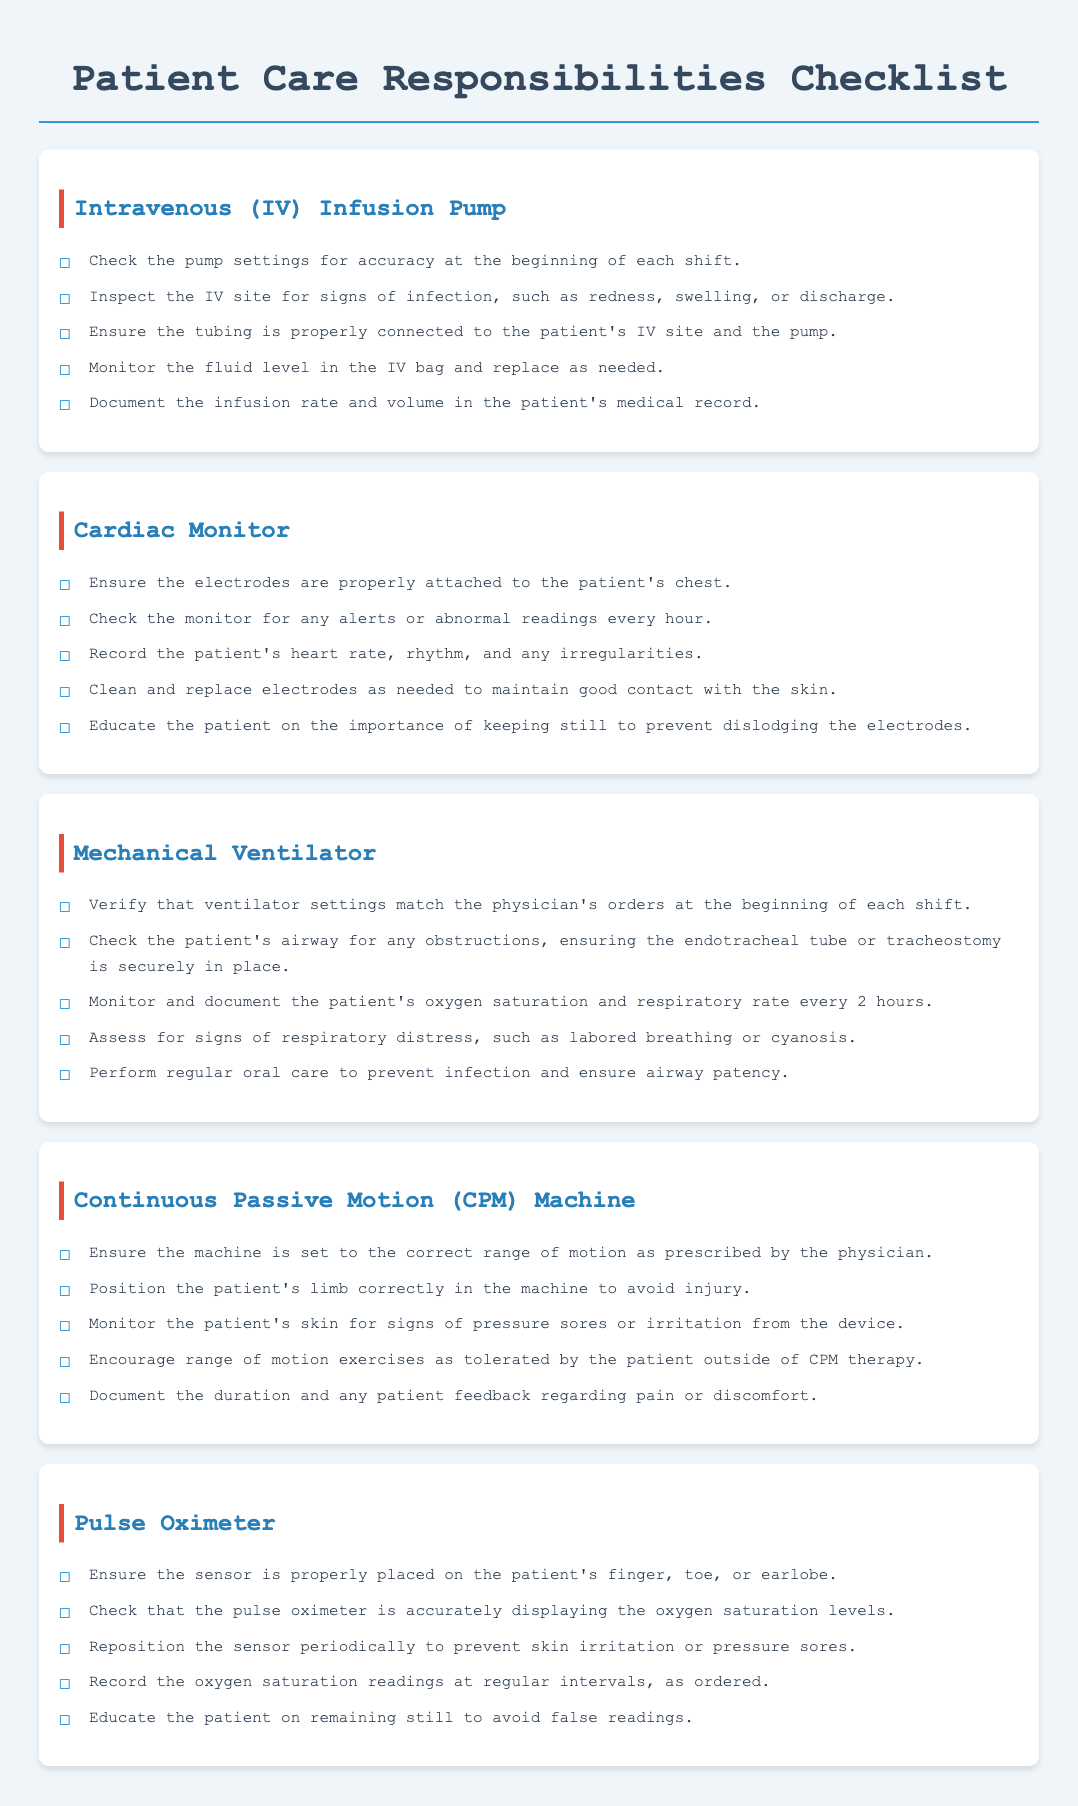What are the responsibilities for an IV infusion pump? The responsibilities for an IV infusion pump are listed in the corresponding section of the document under "Intravenous (IV) Infusion Pump."
Answer: Check the pump settings for accuracy at the beginning of each shift, inspect the IV site for signs of infection, ensure the tubing is properly connected, monitor the fluid level in the IV bag, and document the infusion rate and volume How often should the cardiac monitor be checked for alerts? The document states that the cardiac monitor should be checked for alerts "every hour."
Answer: Every hour What should be documented for the mechanical ventilator? The responsibilities include monitoring and documenting the patient's oxygen saturation and respiratory rate, as well as ventilator settings.
Answer: The patient's oxygen saturation and respiratory rate What is a key patient education point for the pulse oximeter? The document emphasizes that the patient should be educated on remaining still to avoid false readings from the pulse oximeter.
Answer: Remaining still How frequently should skin be monitored when using a CPM machine? The document suggests monitoring the patient's skin for signs of pressure sores or irritation regularly, but does not specify a frequency.
Answer: Regularly What type of device is checked for accuracy at the start of each shift? The document specifies that the IV infusion pump is checked for accuracy at the beginning of each shift.
Answer: IV infusion pump What should be ensured about the patient's airway during ventilator care? The responsibilities mention ensuring the endotracheal tube or tracheostomy is securely in place.
Answer: Securely in place How should the pulse oximeter sensor be placed? The document states that the sensor should be placed on the patient's finger, toe, or earlobe.
Answer: Finger, toe, or earlobe What is the primary purpose of the checklist? The checklist outlines patient care responsibilities for different medical devices used in hospital settings.
Answer: Patient care responsibilities 